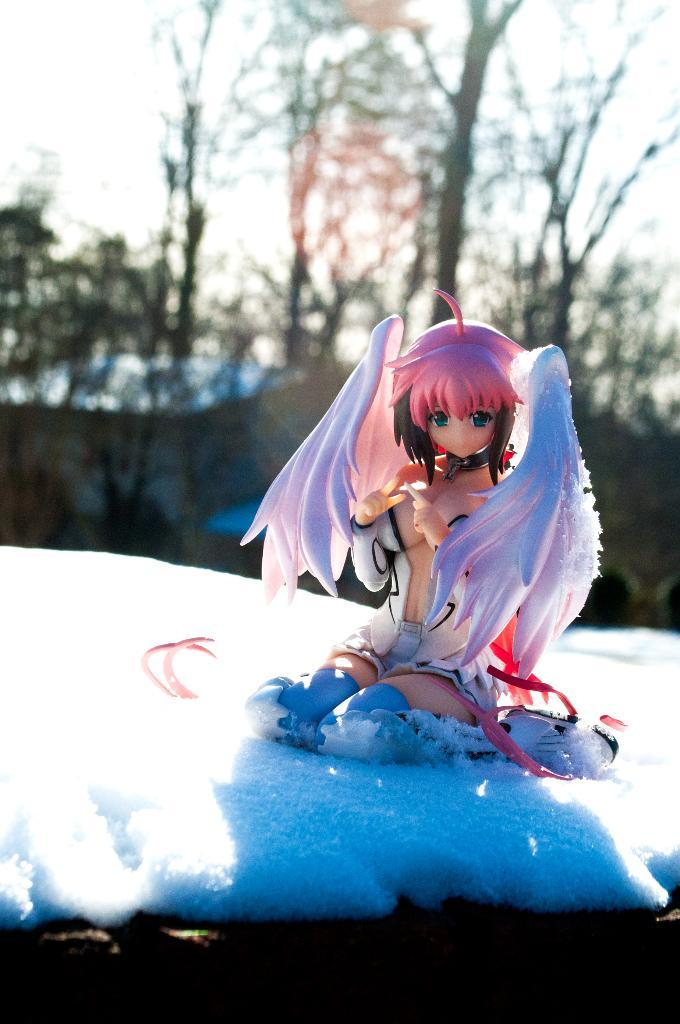What is the main subject of the image? There is a doll in the image. Where is the doll located? The doll is on the snow. What can be seen in the background of the image? There are trees visible in the background of the image. What type of fowl can be seen on the plate in the image? There is no plate or fowl present in the image; it features a doll on the snow with trees in the background. 